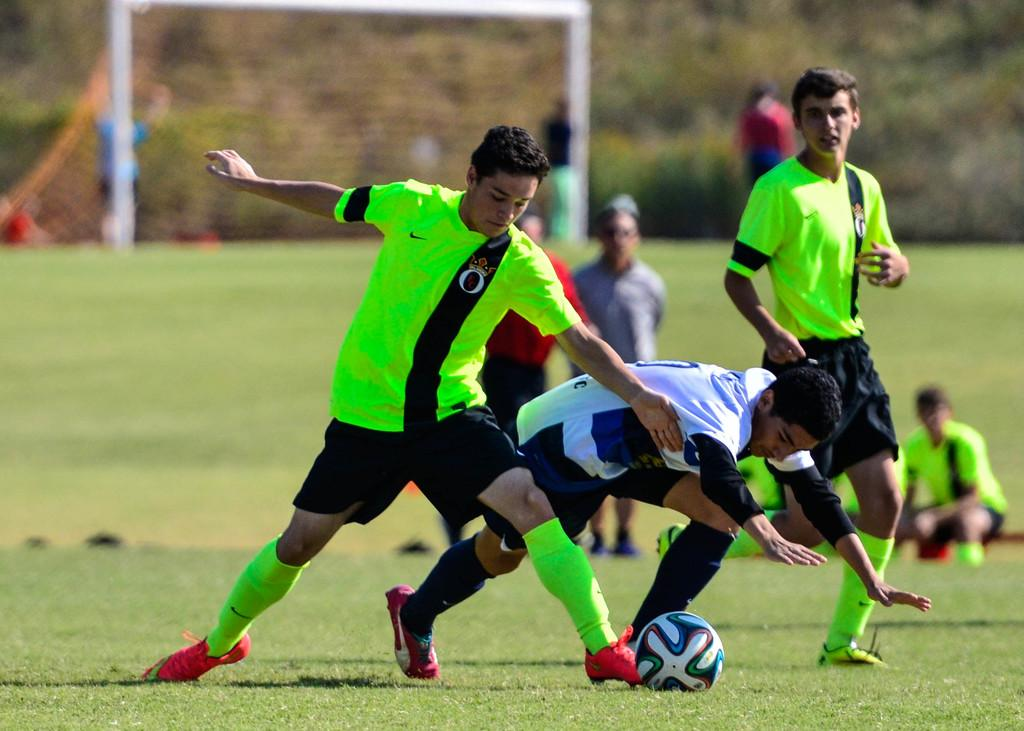How many people are present in the image? There are three people in the image. What can be seen on the grass in the image? There is a ball on the grass. Can you describe the background of the image? The background of the image is blurry. Are there any other people visible besides the three main subjects? Yes, there are people visible in the background. What type of steel is being used to hold the fork in the image? There is no fork present in the image, so it is not possible to determine the type of steel being used. 